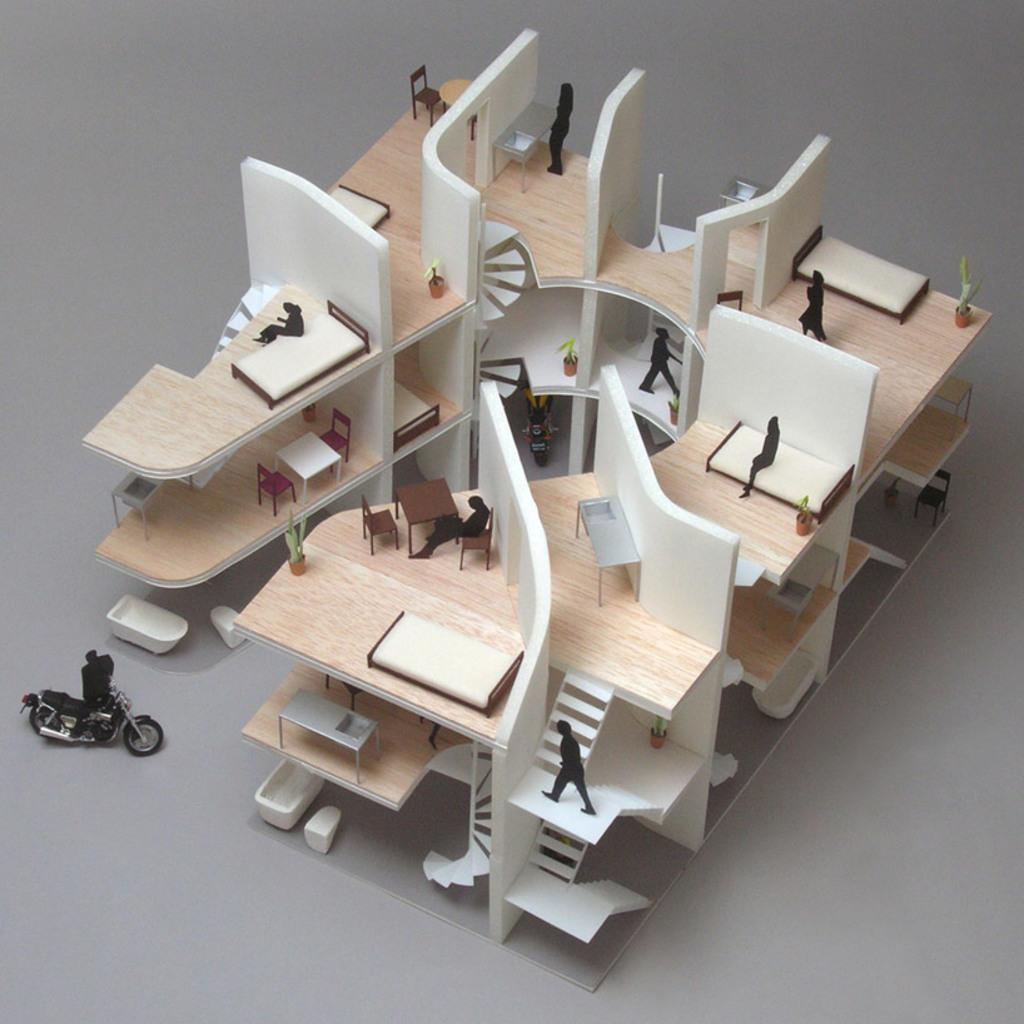What is the main subject of the image? There is a design or drawing related to engineering or architecture in the image. Where is the design or drawing located? The design or drawing is on a table. What type of meat is being represented in the design or drawing on the table? There is no meat present in the design or drawing on the table, as it is related to engineering or architecture. 